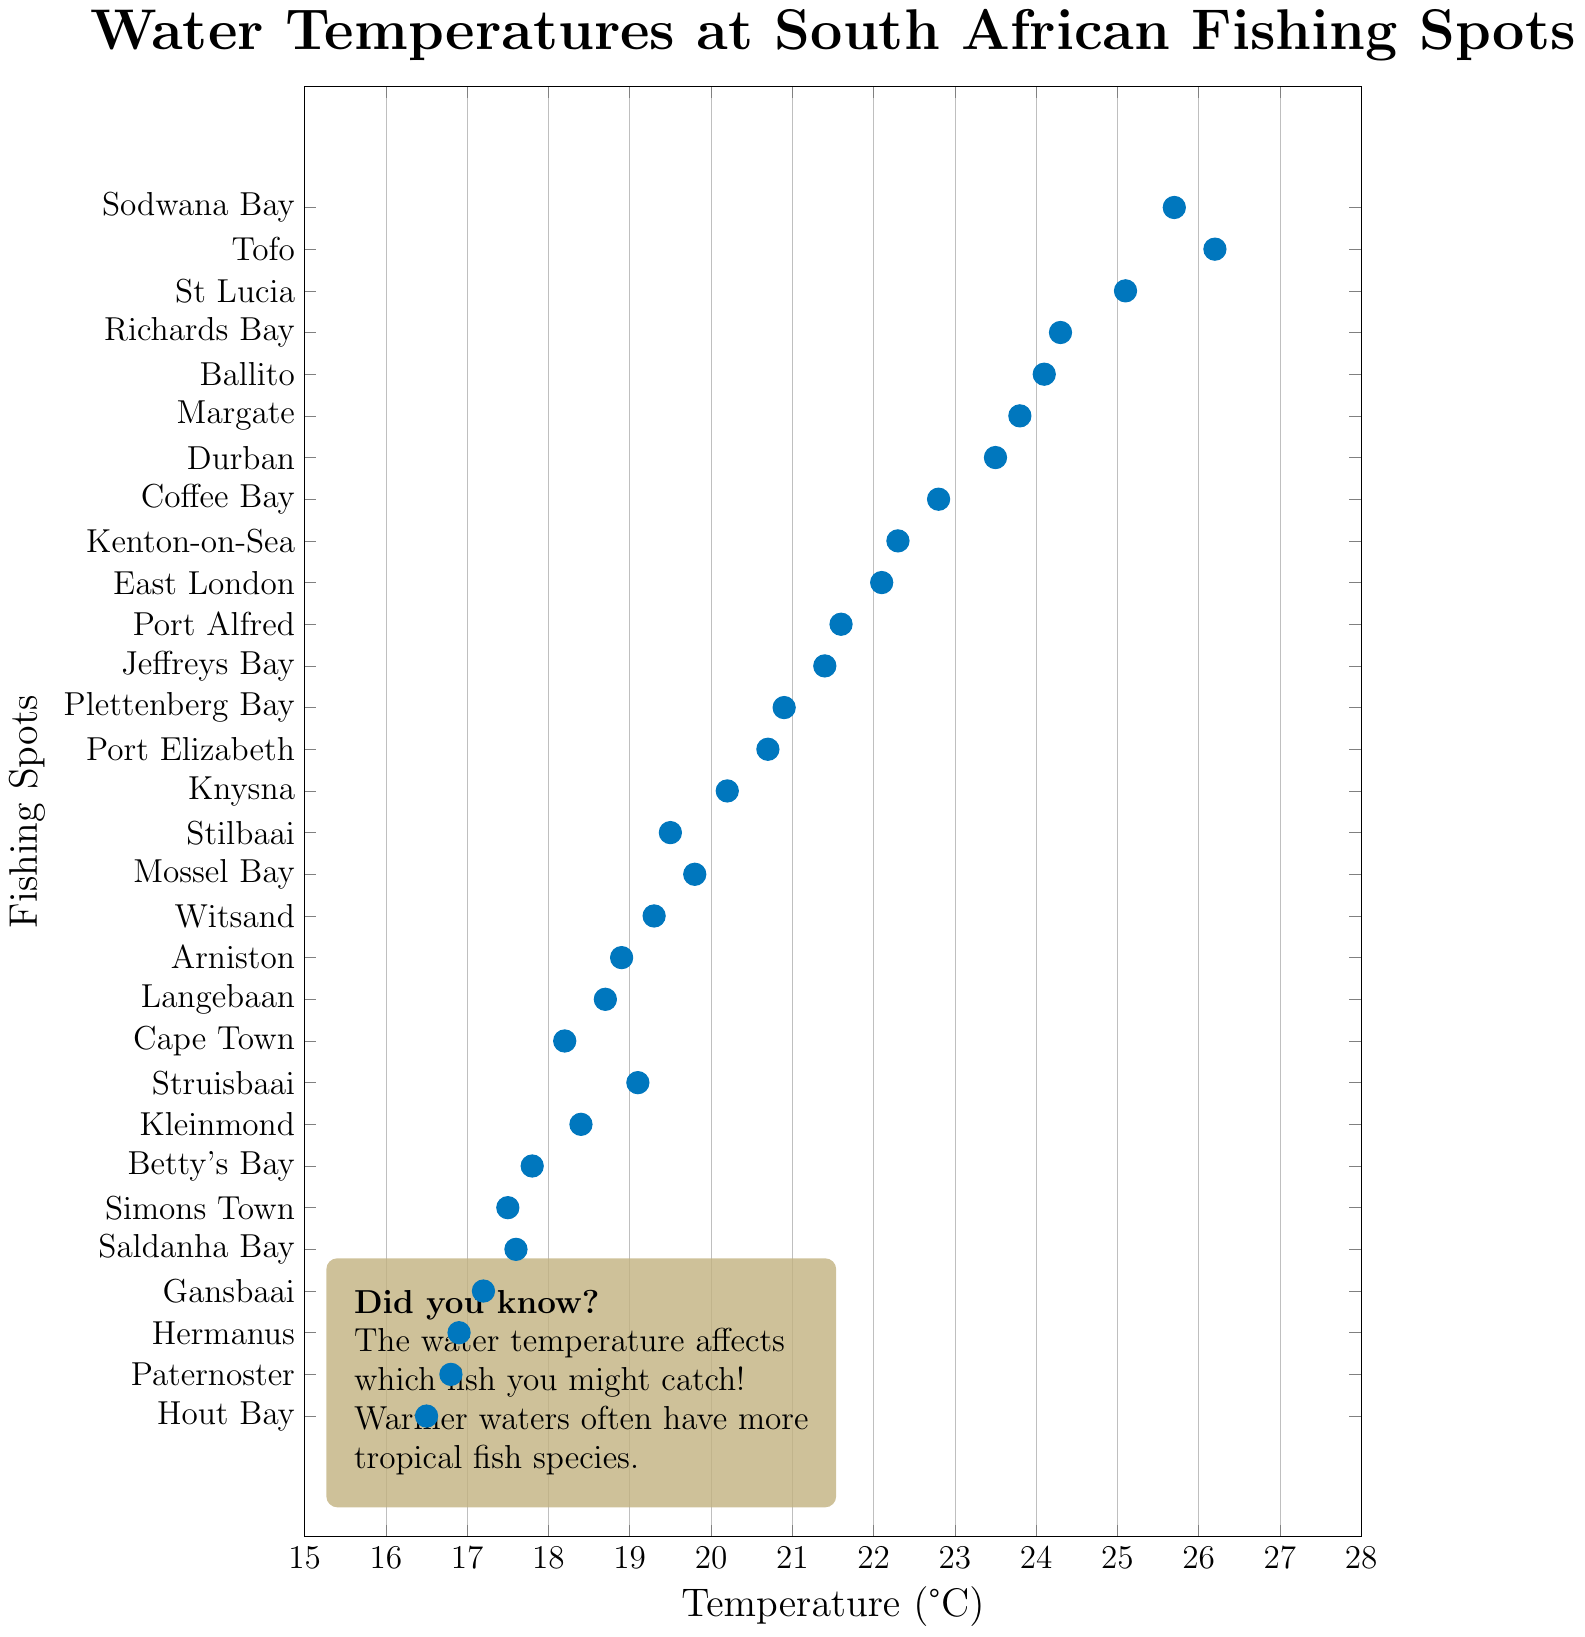What are the three fishing spots with the highest water temperatures? First, identify the three highest temperature values in the figure. Then, note the corresponding fishing spots. Based on the plot, the highest temperatures are 26.2, 25.7, and 25.1°C
Answer: Tofo, Sodwana Bay, St Lucia Which fishing spot has the lowest water temperature and what is its value? Find the lowest temperature point on the plot and look at the corresponding fishing spot. The lowest temperature is 16.5°C
Answer: Hout Bay, 16.5°C How much warmer is the water in Richards Bay compared to Cape Town? Look for the temperatures of Richards Bay and Cape Town. Richards Bay is 24.3°C, and Cape Town is 18.2°C. Subtract the latter from the former: 24.3 - 18.2
Answer: 6.1°C What is the average water temperature of all the fishing spots? Sum all the temperature readings and divide by the number of spots. Sum = 23.5+18.2+20.7+22.1+19.8+24.3+17.6+16.9+21.4+23.8+17.5+20.2+18.7+19.1+25.1+16.8+18.4+20.9+17.2+25.7+17.8+21.6+22.3+18.9+22.8+16.5+19.5+19.3+26.2+24.1; Number of spots = 30. Average = (Sum) / 30
Answer: 20.867°C Is Knysna's water temperature higher or lower than the average temperature of all fishing spots? First, calculate the average temperature (20.867°C). Then, compare it with Knysna's temperature, which is 20.2°C. Since 20.2 is less than 20.867
Answer: Lower Which fishing spot is the closest to 22°C? Find the temperatures in the plot and identify which value is nearest to 22°C. The closest temperatures are 22.1°C (East London) and 21.6°C (Port Alfred), with 22.1°C being closer
Answer: East London How many fishing spots have a water temperature above 22°C? Count the number of spots with a temperature greater than 22°C. The temperatures with values above 22°C are 23.5, 24.3, 25.1, 23.8, 24.1, 25.7, 26.2, 22.8, 22.3, 22.1
Answer: 10 Which fishing spots have temperatures below 17°C? Identify all the spots with a temperature less than 17°C. The temperatures below 17°C are 16.5, 16.8, 16.9, 17.2
Answer: Hout Bay, Paternoster, Hermanus, Gansbaai 